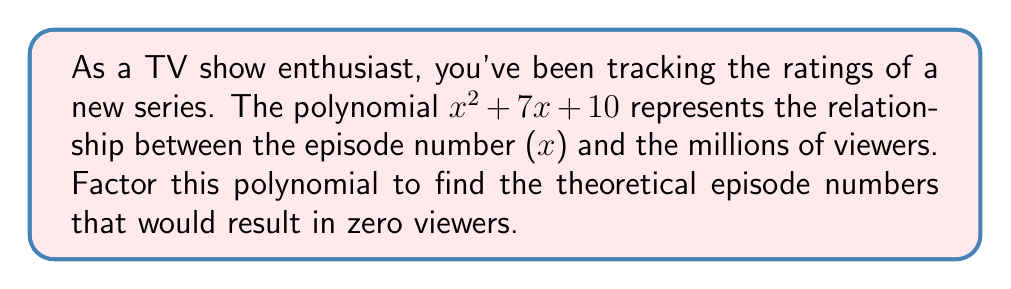Can you solve this math problem? To factor this quadratic polynomial, we'll use the following steps:

1) First, identify the coefficients:
   $a = 1$, $b = 7$, and $c = 10$

2) We need to find two numbers that multiply to give $ac = 1 \times 10 = 10$ and add up to $b = 7$.
   These numbers are 5 and 2.

3) Rewrite the middle term using these numbers:
   $x^2 + 5x + 2x + 10$

4) Group the terms:
   $(x^2 + 5x) + (2x + 10)$

5) Factor out the common factor from each group:
   $x(x + 5) + 2(x + 5)$

6) Factor out the common binomial $(x + 5)$:
   $(x + 5)(x + 2)$

Therefore, the factored form of $x^2 + 7x + 10$ is $(x + 5)(x + 2)$.

The roots of this polynomial (where it equals zero) would be at $x = -5$ and $x = -2$. However, in the context of TV show episodes, negative episode numbers don't make sense. This implies that there are no realistic episode numbers that would result in zero viewers according to this model.
Answer: $(x + 5)(x + 2)$ 